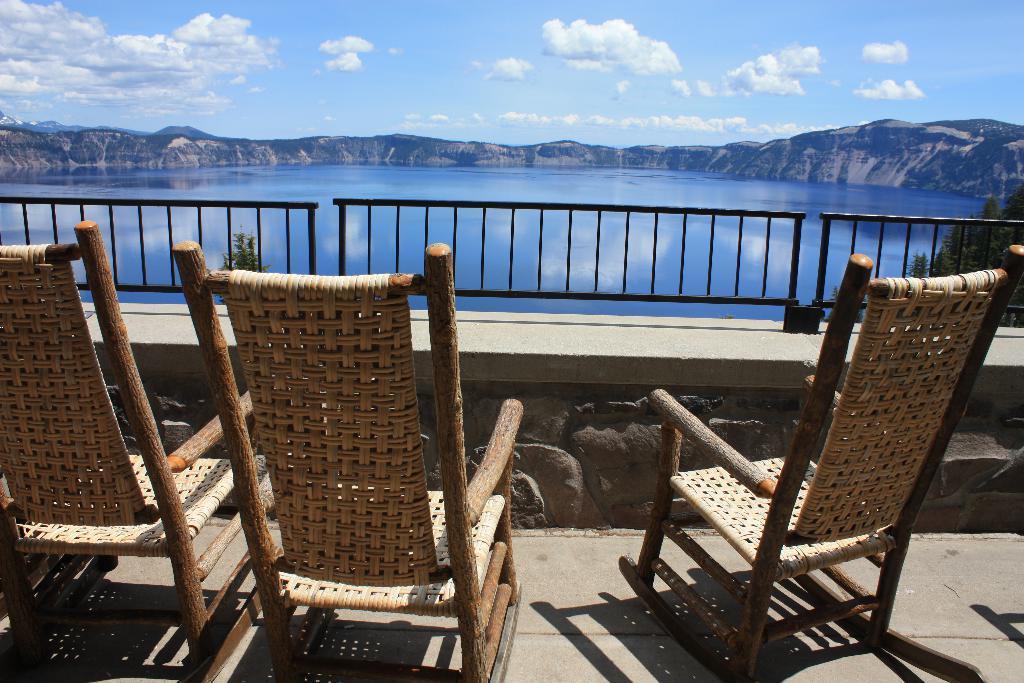Please provide a concise description of this image. In the foreground of the image there are chairs. There is a fencing. At the background of the image there are mountains. There is water. At the top of the image there is sky and clouds. 